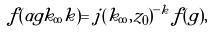<formula> <loc_0><loc_0><loc_500><loc_500>f ( \alpha g k _ { \infty } k ) = j ( k _ { \infty } , z _ { 0 } ) ^ { - k } f ( g ) ,</formula> 